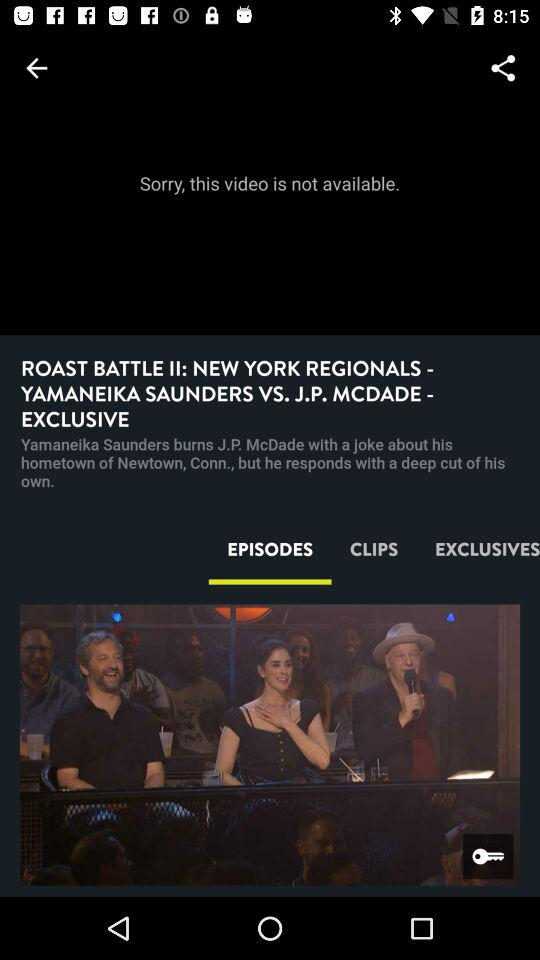What is the title of the video? The title of the video is "ROAST BATTLE II: NEW YORK REGIONALS - YAMANEIKA SAUNDERS VS. J.P. MCDADE - EXCLUSIVE". 